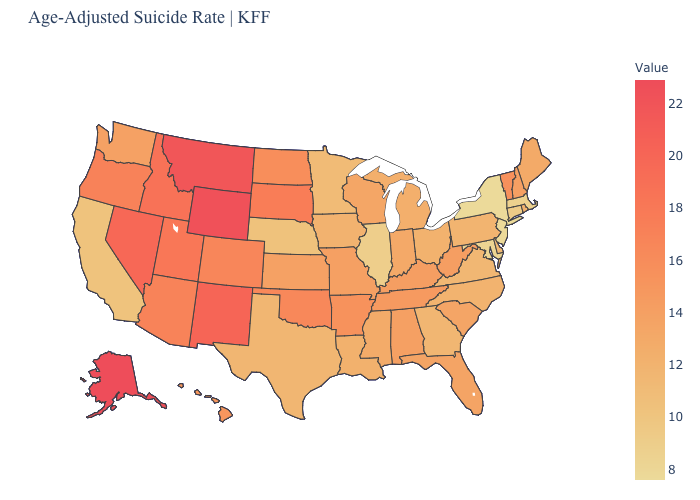Does Vermont have the highest value in the Northeast?
Concise answer only. Yes. Does South Dakota have the highest value in the MidWest?
Be succinct. Yes. Does Illinois have the lowest value in the MidWest?
Quick response, please. Yes. Among the states that border Maine , which have the highest value?
Answer briefly. New Hampshire. Does Oregon have a higher value than Michigan?
Concise answer only. Yes. Among the states that border Kentucky , does Tennessee have the lowest value?
Keep it brief. No. Which states have the lowest value in the USA?
Quick response, please. New York. Among the states that border Kansas , does Colorado have the highest value?
Be succinct. Yes. Does Oregon have a higher value than Indiana?
Concise answer only. Yes. 